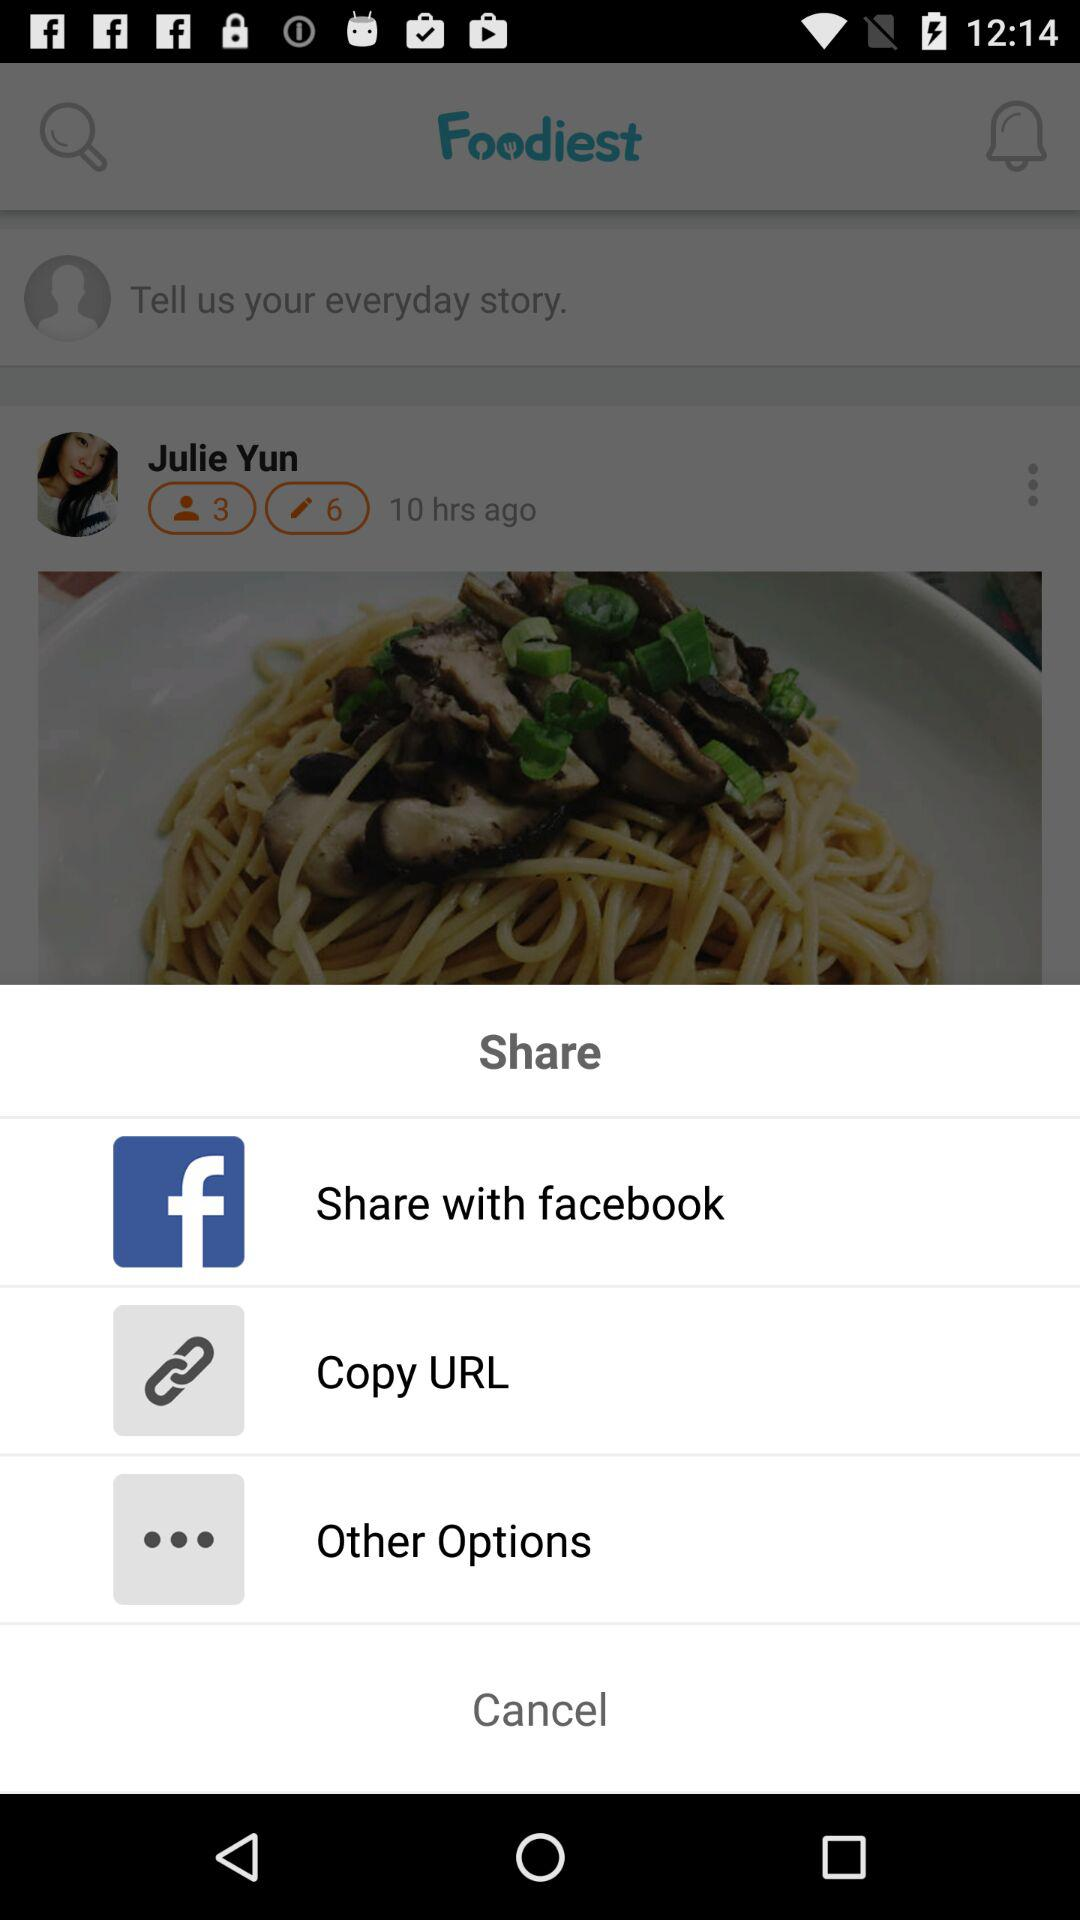What are the sharing options? The sharing options are "facebook", "Copy URL" and "Other Options". 